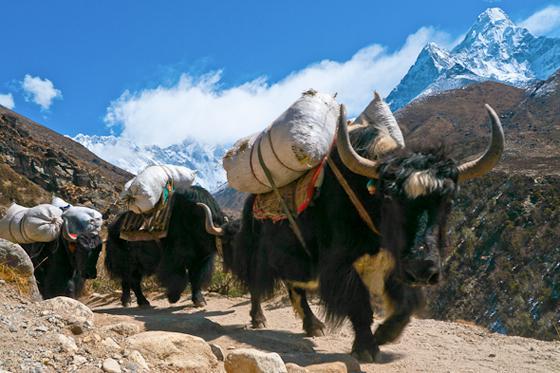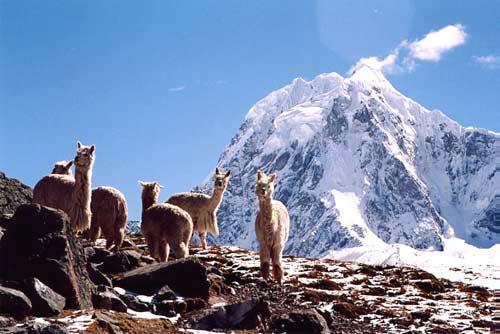The first image is the image on the left, the second image is the image on the right. For the images shown, is this caption "At least three animals are on the mountain together in each picture." true? Answer yes or no. Yes. The first image is the image on the left, the second image is the image on the right. For the images shown, is this caption "In one image, a single llama without a pack is standing on a cliff edge overlooking scenery with mountains in the background." true? Answer yes or no. No. 